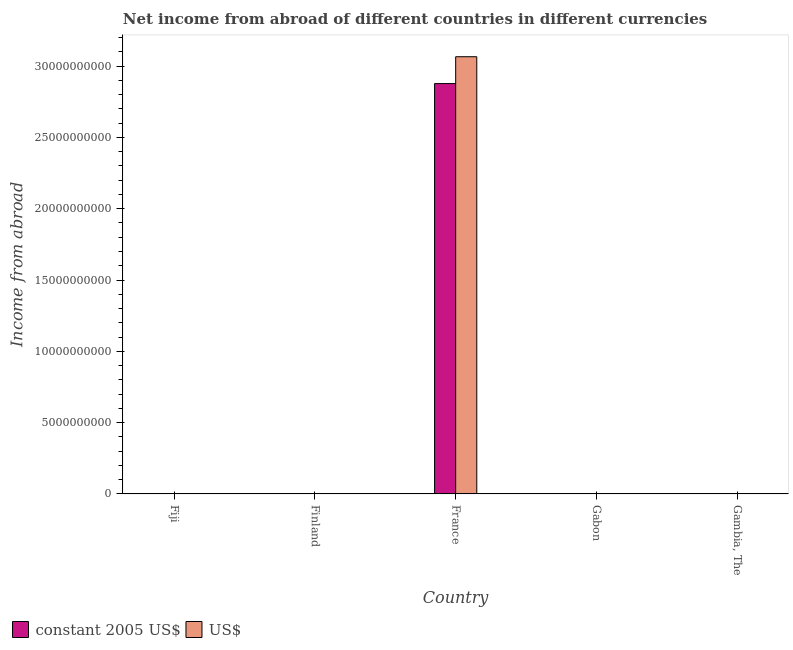How many different coloured bars are there?
Provide a short and direct response. 2. Are the number of bars on each tick of the X-axis equal?
Provide a short and direct response. No. How many bars are there on the 1st tick from the left?
Ensure brevity in your answer.  0. What is the label of the 4th group of bars from the left?
Your answer should be very brief. Gabon. Across all countries, what is the maximum income from abroad in us$?
Make the answer very short. 3.07e+1. Across all countries, what is the minimum income from abroad in constant 2005 us$?
Keep it short and to the point. 0. What is the total income from abroad in us$ in the graph?
Give a very brief answer. 3.07e+1. What is the difference between the income from abroad in us$ in Finland and the income from abroad in constant 2005 us$ in France?
Provide a succinct answer. -2.88e+1. What is the average income from abroad in constant 2005 us$ per country?
Give a very brief answer. 5.76e+09. What is the difference between the income from abroad in us$ and income from abroad in constant 2005 us$ in France?
Make the answer very short. 1.88e+09. What is the difference between the highest and the lowest income from abroad in us$?
Your response must be concise. 3.07e+1. Are all the bars in the graph horizontal?
Provide a succinct answer. No. How many countries are there in the graph?
Offer a very short reply. 5. Are the values on the major ticks of Y-axis written in scientific E-notation?
Keep it short and to the point. No. How many legend labels are there?
Your answer should be very brief. 2. What is the title of the graph?
Provide a succinct answer. Net income from abroad of different countries in different currencies. What is the label or title of the Y-axis?
Give a very brief answer. Income from abroad. What is the Income from abroad of US$ in Finland?
Keep it short and to the point. 0. What is the Income from abroad in constant 2005 US$ in France?
Provide a short and direct response. 2.88e+1. What is the Income from abroad of US$ in France?
Offer a very short reply. 3.07e+1. What is the Income from abroad of US$ in Gabon?
Provide a succinct answer. 0. What is the Income from abroad in US$ in Gambia, The?
Your response must be concise. 0. Across all countries, what is the maximum Income from abroad of constant 2005 US$?
Your response must be concise. 2.88e+1. Across all countries, what is the maximum Income from abroad of US$?
Offer a very short reply. 3.07e+1. What is the total Income from abroad of constant 2005 US$ in the graph?
Your response must be concise. 2.88e+1. What is the total Income from abroad in US$ in the graph?
Your response must be concise. 3.07e+1. What is the average Income from abroad in constant 2005 US$ per country?
Your answer should be very brief. 5.76e+09. What is the average Income from abroad in US$ per country?
Your answer should be compact. 6.13e+09. What is the difference between the Income from abroad in constant 2005 US$ and Income from abroad in US$ in France?
Your answer should be compact. -1.88e+09. What is the difference between the highest and the lowest Income from abroad in constant 2005 US$?
Ensure brevity in your answer.  2.88e+1. What is the difference between the highest and the lowest Income from abroad in US$?
Ensure brevity in your answer.  3.07e+1. 